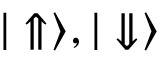Convert formula to latex. <formula><loc_0><loc_0><loc_500><loc_500>{ | \Uparrow \rangle , | \Downarrow \rangle }</formula> 